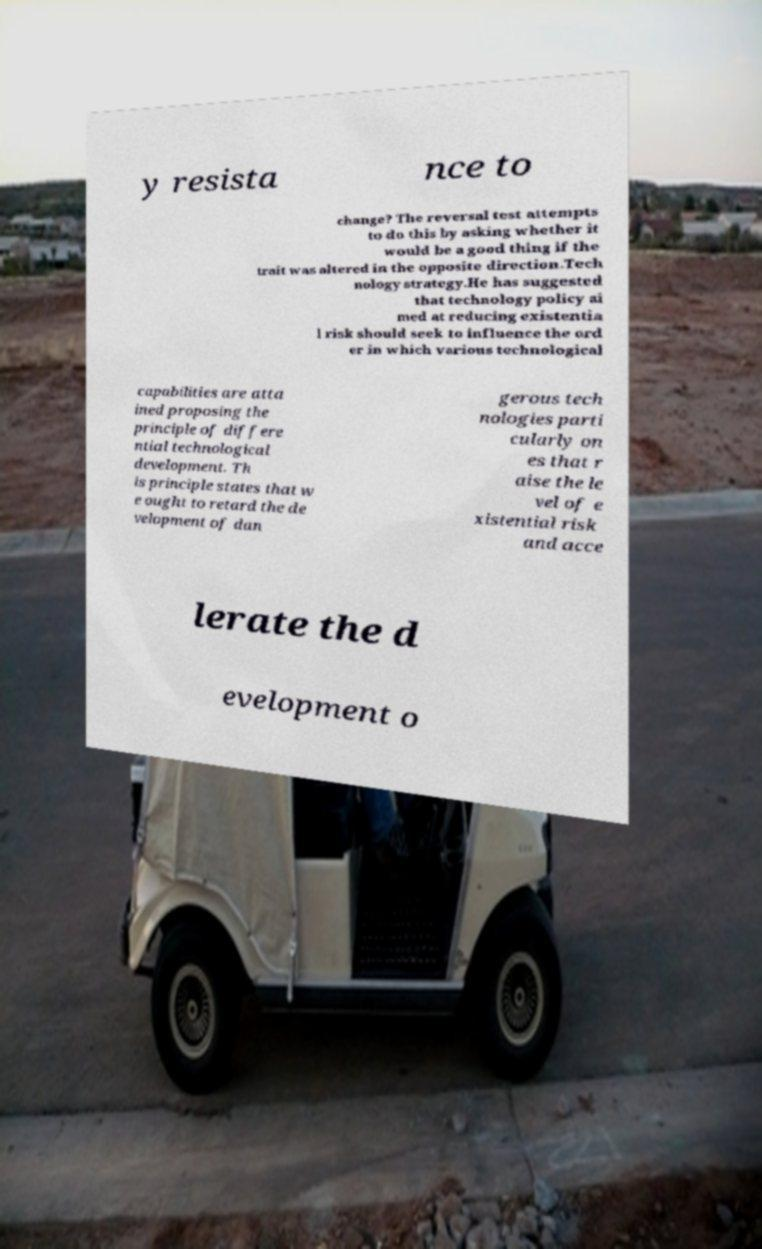Can you accurately transcribe the text from the provided image for me? y resista nce to change? The reversal test attempts to do this by asking whether it would be a good thing if the trait was altered in the opposite direction.Tech nology strategy.He has suggested that technology policy ai med at reducing existentia l risk should seek to influence the ord er in which various technological capabilities are atta ined proposing the principle of differe ntial technological development. Th is principle states that w e ought to retard the de velopment of dan gerous tech nologies parti cularly on es that r aise the le vel of e xistential risk and acce lerate the d evelopment o 